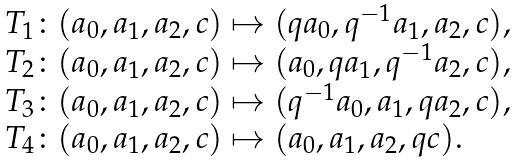<formula> <loc_0><loc_0><loc_500><loc_500>\begin{array} { l } T _ { 1 } \colon ( a _ { 0 } , a _ { 1 } , a _ { 2 } , c ) \mapsto ( q a _ { 0 } , q ^ { - 1 } a _ { 1 } , a _ { 2 } , c ) , \\ T _ { 2 } \colon ( a _ { 0 } , a _ { 1 } , a _ { 2 } , c ) \mapsto ( a _ { 0 } , q a _ { 1 } , q ^ { - 1 } a _ { 2 } , c ) , \\ T _ { 3 } \colon ( a _ { 0 } , a _ { 1 } , a _ { 2 } , c ) \mapsto ( q ^ { - 1 } a _ { 0 } , a _ { 1 } , q a _ { 2 } , c ) , \\ T _ { 4 } \colon ( a _ { 0 } , a _ { 1 } , a _ { 2 } , c ) \mapsto ( a _ { 0 } , a _ { 1 } , a _ { 2 } , q c ) . \end{array}</formula> 